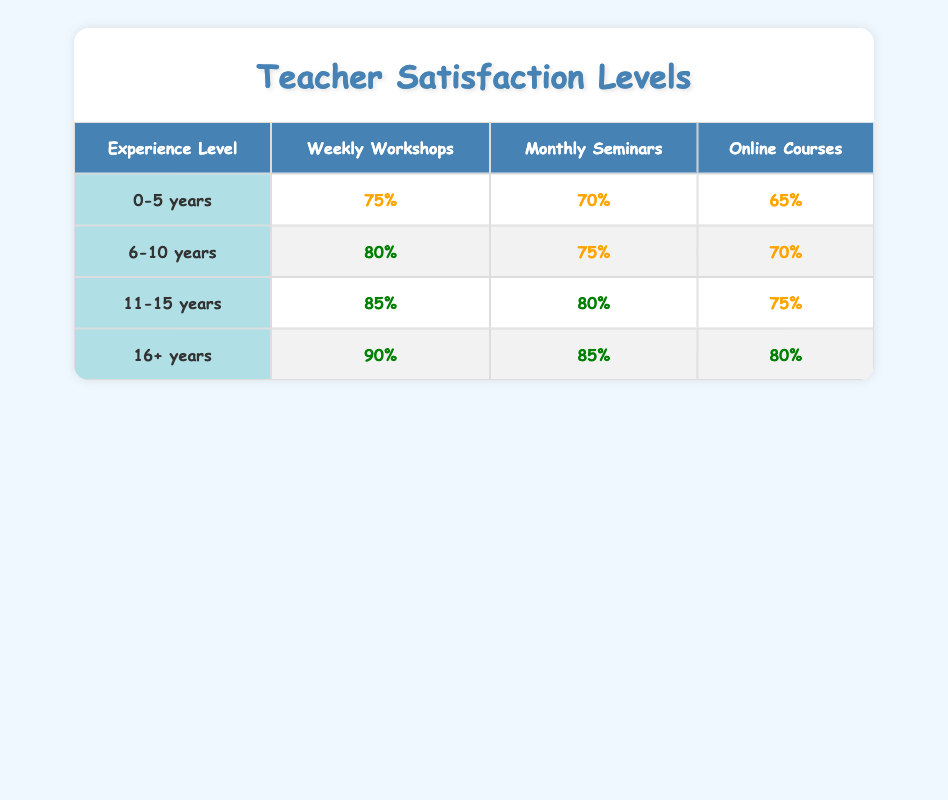What is the satisfaction level for teachers with 16+ years of experience attending Weekly Workshops? The table shows that for teachers with 16+ years of experience, the satisfaction level for Weekly Workshops is 90%.
Answer: 90% Which professional development opportunity has the highest satisfaction level for teachers with 11-15 years of experience? In the table, for teachers with 11-15 years of experience, the satisfaction levels are 85% for Weekly Workshops, 80% for Monthly Seminars, and 75% for Online Courses. The highest satisfaction level is 85% for Weekly Workshops.
Answer: 85% Is the satisfaction level for Online Courses higher for teachers with 6-10 years or 0-5 years of experience? The satisfaction level for Online Courses for teachers with 6-10 years of experience is 70%, while for those with 0-5 years of experience, it is 65%. Since 70% is greater than 65%, the satisfaction level is higher for teachers with 6-10 years of experience.
Answer: Yes What is the average satisfaction level for teachers participating in Monthly Seminars across all experience levels? The satisfaction levels for Monthly Seminars across all experience levels are 70% (0-5 years), 75% (6-10 years), 80% (11-15 years), and 85% (16+ years). Summing these values gives 70 + 75 + 80 + 85 = 310. Dividing by 4 (the number of experience levels) results in an average of 310 / 4 = 77.5%.
Answer: 77.5% Does the satisfaction level increase or decrease from 0-5 years to 6-10 years for Weekly Workshops? The satisfaction level for Weekly Workshops for 0-5 years of experience is 75%, and for 6-10 years, it is 80%. Since 80% is greater than 75%, the satisfaction level increases.
Answer: Increase 